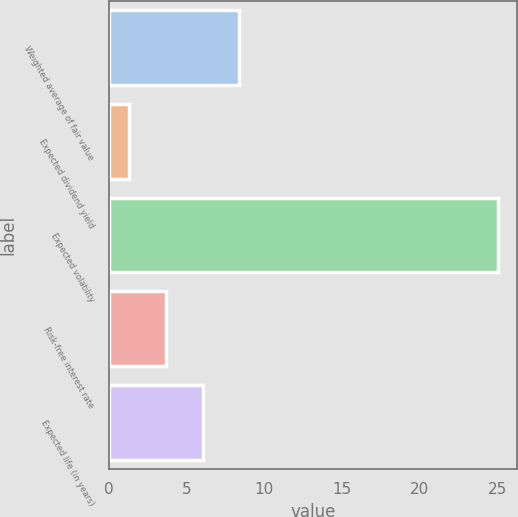<chart> <loc_0><loc_0><loc_500><loc_500><bar_chart><fcel>Weighted average of fair value<fcel>Expected dividend yield<fcel>Expected volatility<fcel>Risk-free interest rate<fcel>Expected life (in years)<nl><fcel>8.41<fcel>1.3<fcel>25<fcel>3.67<fcel>6.04<nl></chart> 